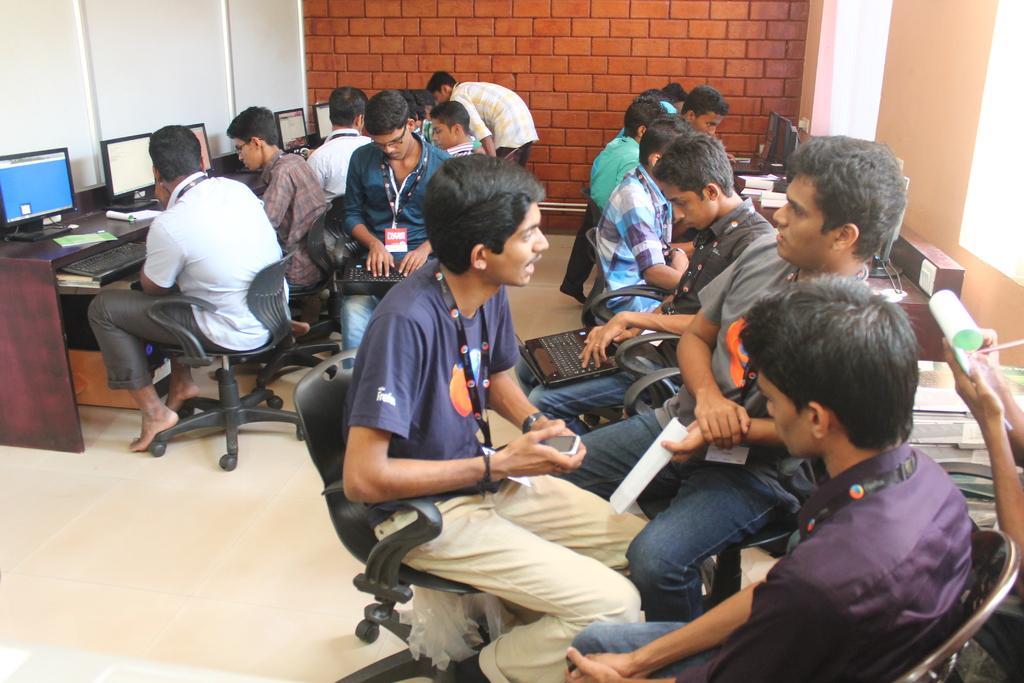Could you give a brief overview of what you see in this image? There are few persons sitting in chairs where two among them are operating laptops in front of them and the background wall is in brick color. 